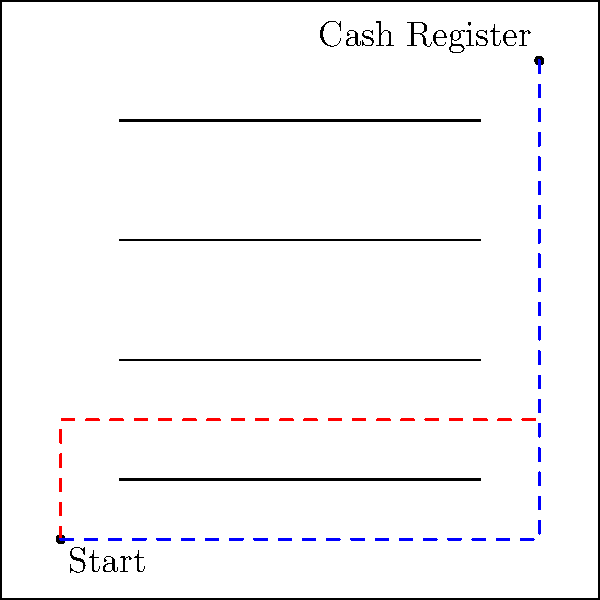In your maze-like liquor store, you need to get from the entrance to the cash register as quickly as possible to ring up a customer's overpriced booze. The store layout is shown above, with shelves represented by horizontal lines. Two possible paths are drawn: the red dashed line going around three shelves, and the blue dashed line going around one shelf. Which path is shorter, and by how much? Assume the store is 100 units wide and 100 units tall, with the start point at (10,10) and the cash register at (90,90). Let's break this down step-by-step:

1) First, let's calculate the length of the red path:
   - From (10,10) to (10,30): 20 units
   - From (10,30) to (90,30): 80 units
   - From (90,30) to (90,90): 60 units
   Total red path: $20 + 80 + 60 = 160$ units

2) Now, let's calculate the length of the blue path:
   - From (10,10) to (90,10): 80 units
   - From (90,10) to (90,90): 80 units
   Total blue path: $80 + 80 = 160$ units

3) Surprisingly, both paths have the same length of 160 units.

4) The difference in length is: $160 - 160 = 0$ units

This counterintuitive result is an example of the "Manhattan distance" or "taxicab geometry," where the shortest path between two points is not always unique in a grid-like layout.
Answer: Neither path is shorter; both are 160 units long. 